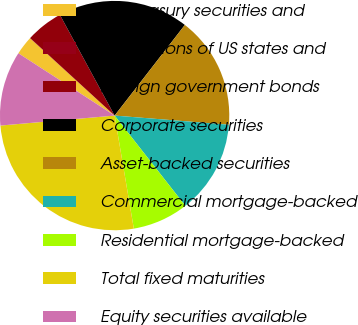Convert chart. <chart><loc_0><loc_0><loc_500><loc_500><pie_chart><fcel>US Treasury securities and<fcel>Obligations of US states and<fcel>Foreign government bonds<fcel>Corporate securities<fcel>Asset-backed securities<fcel>Commercial mortgage-backed<fcel>Residential mortgage-backed<fcel>Total fixed maturities<fcel>Equity securities available<nl><fcel>2.65%<fcel>0.02%<fcel>5.27%<fcel>18.41%<fcel>15.78%<fcel>13.15%<fcel>7.9%<fcel>26.29%<fcel>10.53%<nl></chart> 